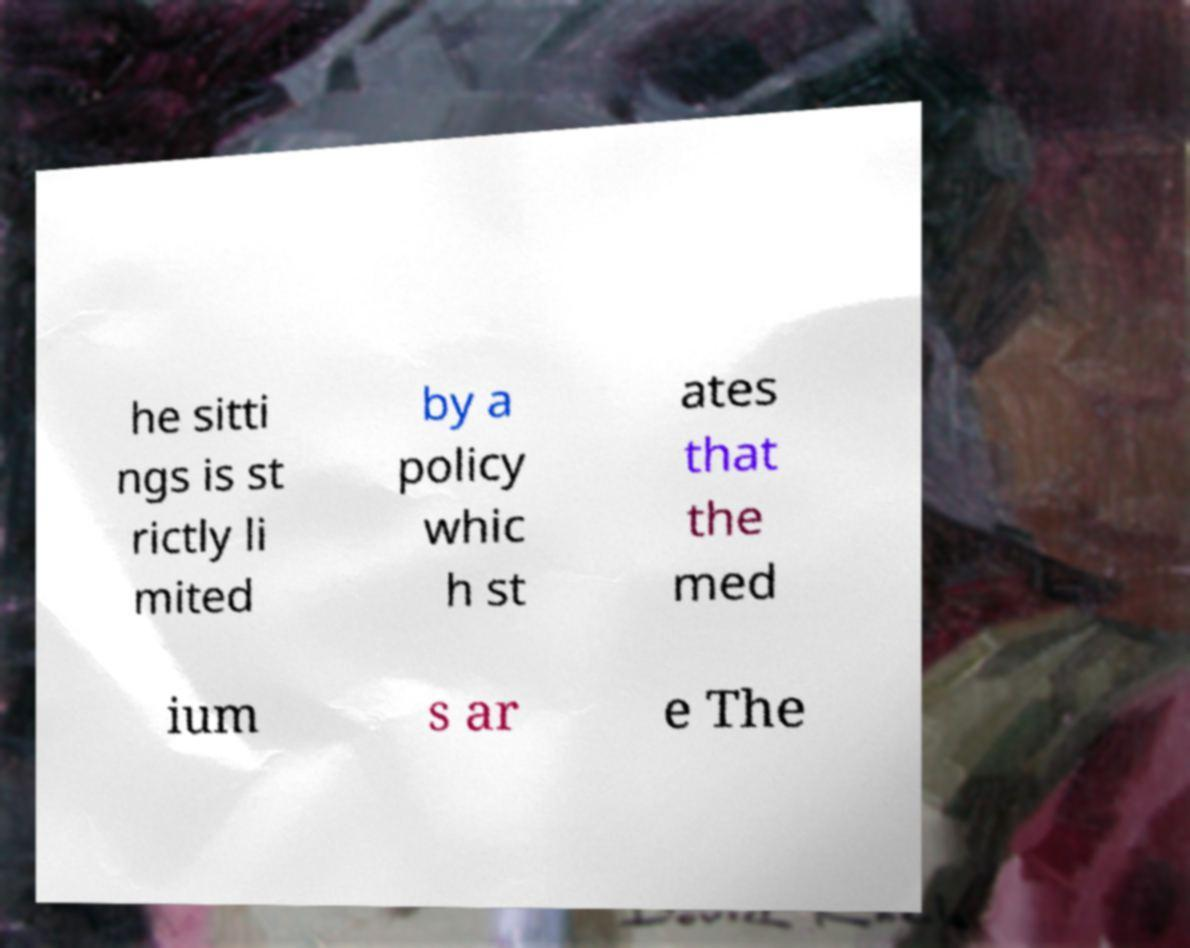There's text embedded in this image that I need extracted. Can you transcribe it verbatim? he sitti ngs is st rictly li mited by a policy whic h st ates that the med ium s ar e The 